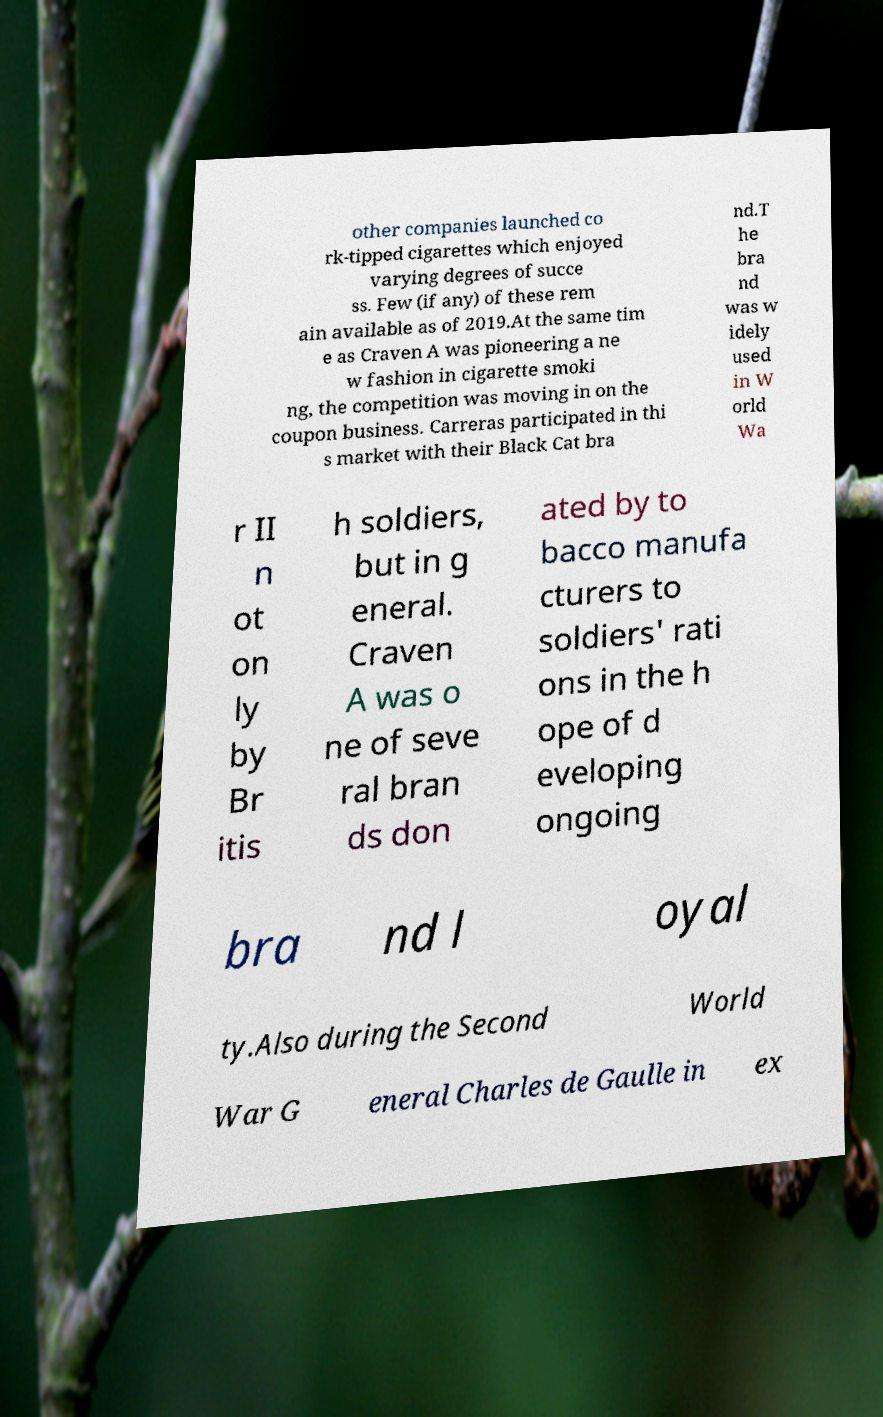What messages or text are displayed in this image? I need them in a readable, typed format. other companies launched co rk-tipped cigarettes which enjoyed varying degrees of succe ss. Few (if any) of these rem ain available as of 2019.At the same tim e as Craven A was pioneering a ne w fashion in cigarette smoki ng, the competition was moving in on the coupon business. Carreras participated in thi s market with their Black Cat bra nd.T he bra nd was w idely used in W orld Wa r II n ot on ly by Br itis h soldiers, but in g eneral. Craven A was o ne of seve ral bran ds don ated by to bacco manufa cturers to soldiers' rati ons in the h ope of d eveloping ongoing bra nd l oyal ty.Also during the Second World War G eneral Charles de Gaulle in ex 